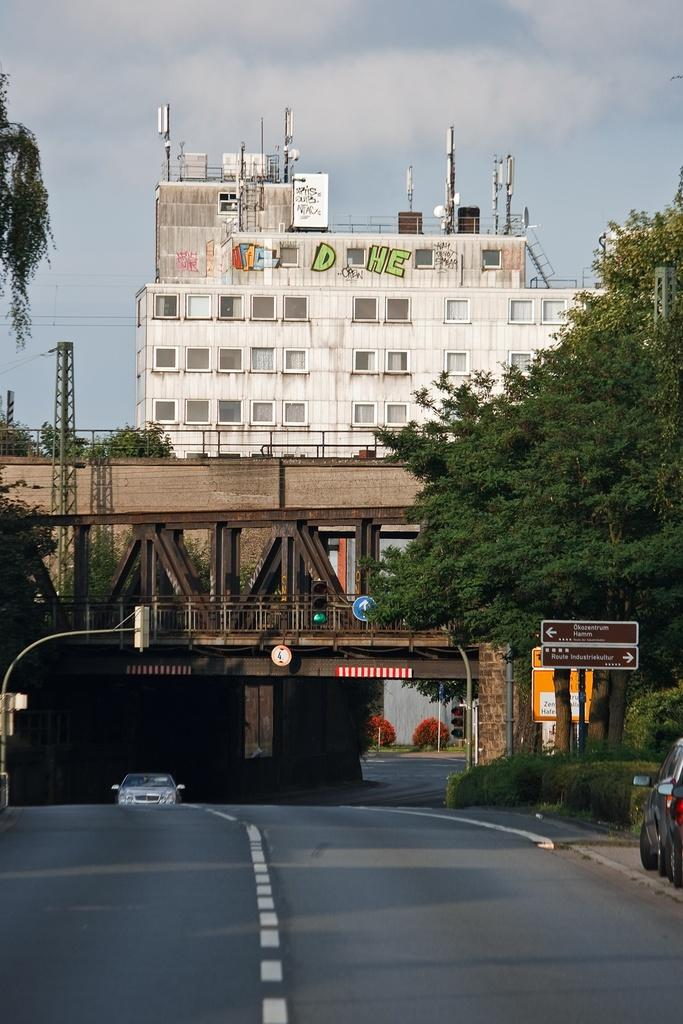What type of vehicle is on the road in the image? There is a car on the road in the image. What structure can be seen in the image that allows vehicles to cross over a body of water? There is a bridge in the image. What type of natural vegetation is present in the image? There are trees in the image. What type of man-made structure is visible in the image? There is a building in the image. What is visible in the background of the image? The sky is visible in the background of the image. What type of cream is being used to judge the lock in the image? There is no cream, judge, or lock present in the image. 